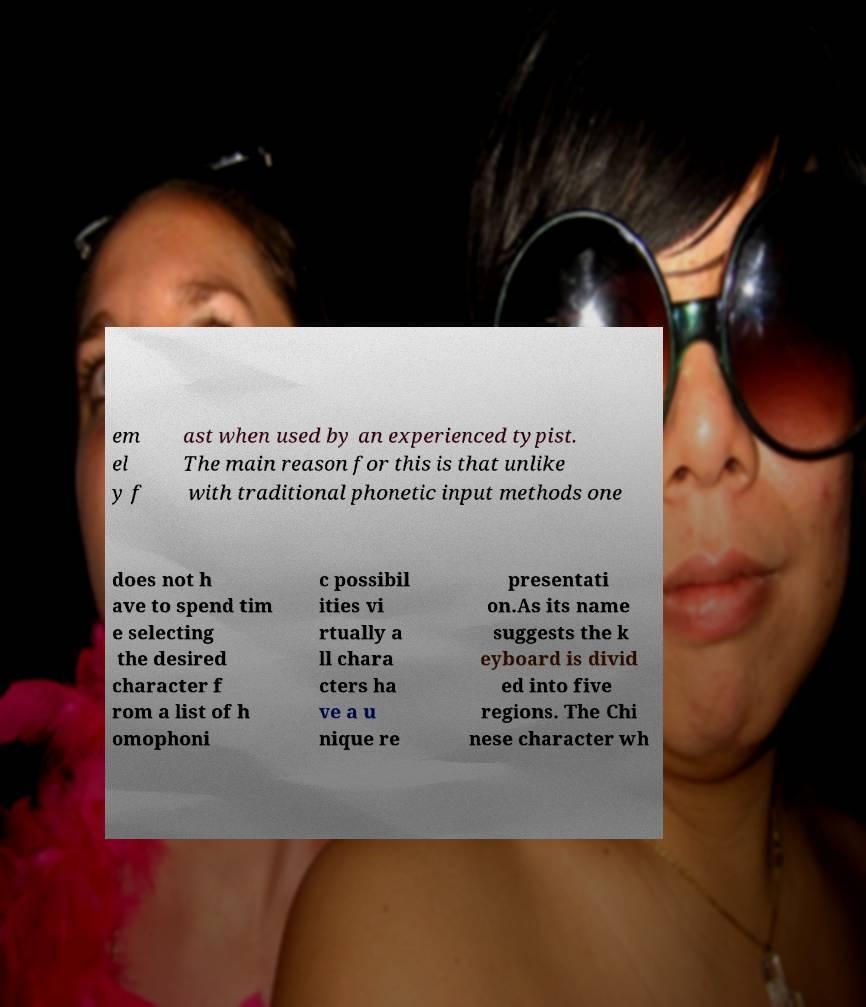I need the written content from this picture converted into text. Can you do that? em el y f ast when used by an experienced typist. The main reason for this is that unlike with traditional phonetic input methods one does not h ave to spend tim e selecting the desired character f rom a list of h omophoni c possibil ities vi rtually a ll chara cters ha ve a u nique re presentati on.As its name suggests the k eyboard is divid ed into five regions. The Chi nese character wh 